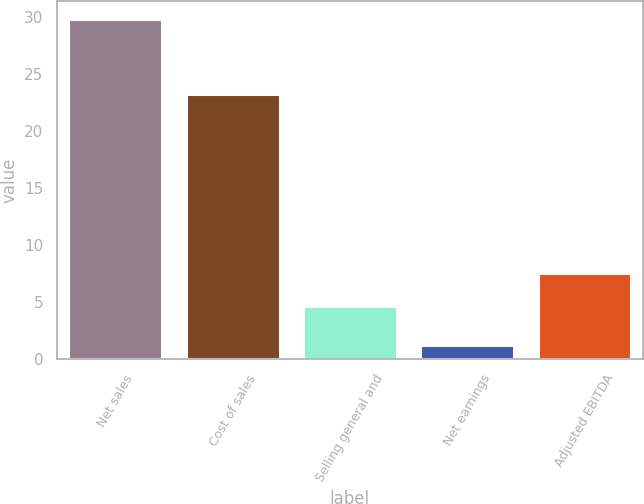<chart> <loc_0><loc_0><loc_500><loc_500><bar_chart><fcel>Net sales<fcel>Cost of sales<fcel>Selling general and<fcel>Net earnings<fcel>Adjusted EBITDA<nl><fcel>29.9<fcel>23.3<fcel>4.7<fcel>1.2<fcel>7.57<nl></chart> 